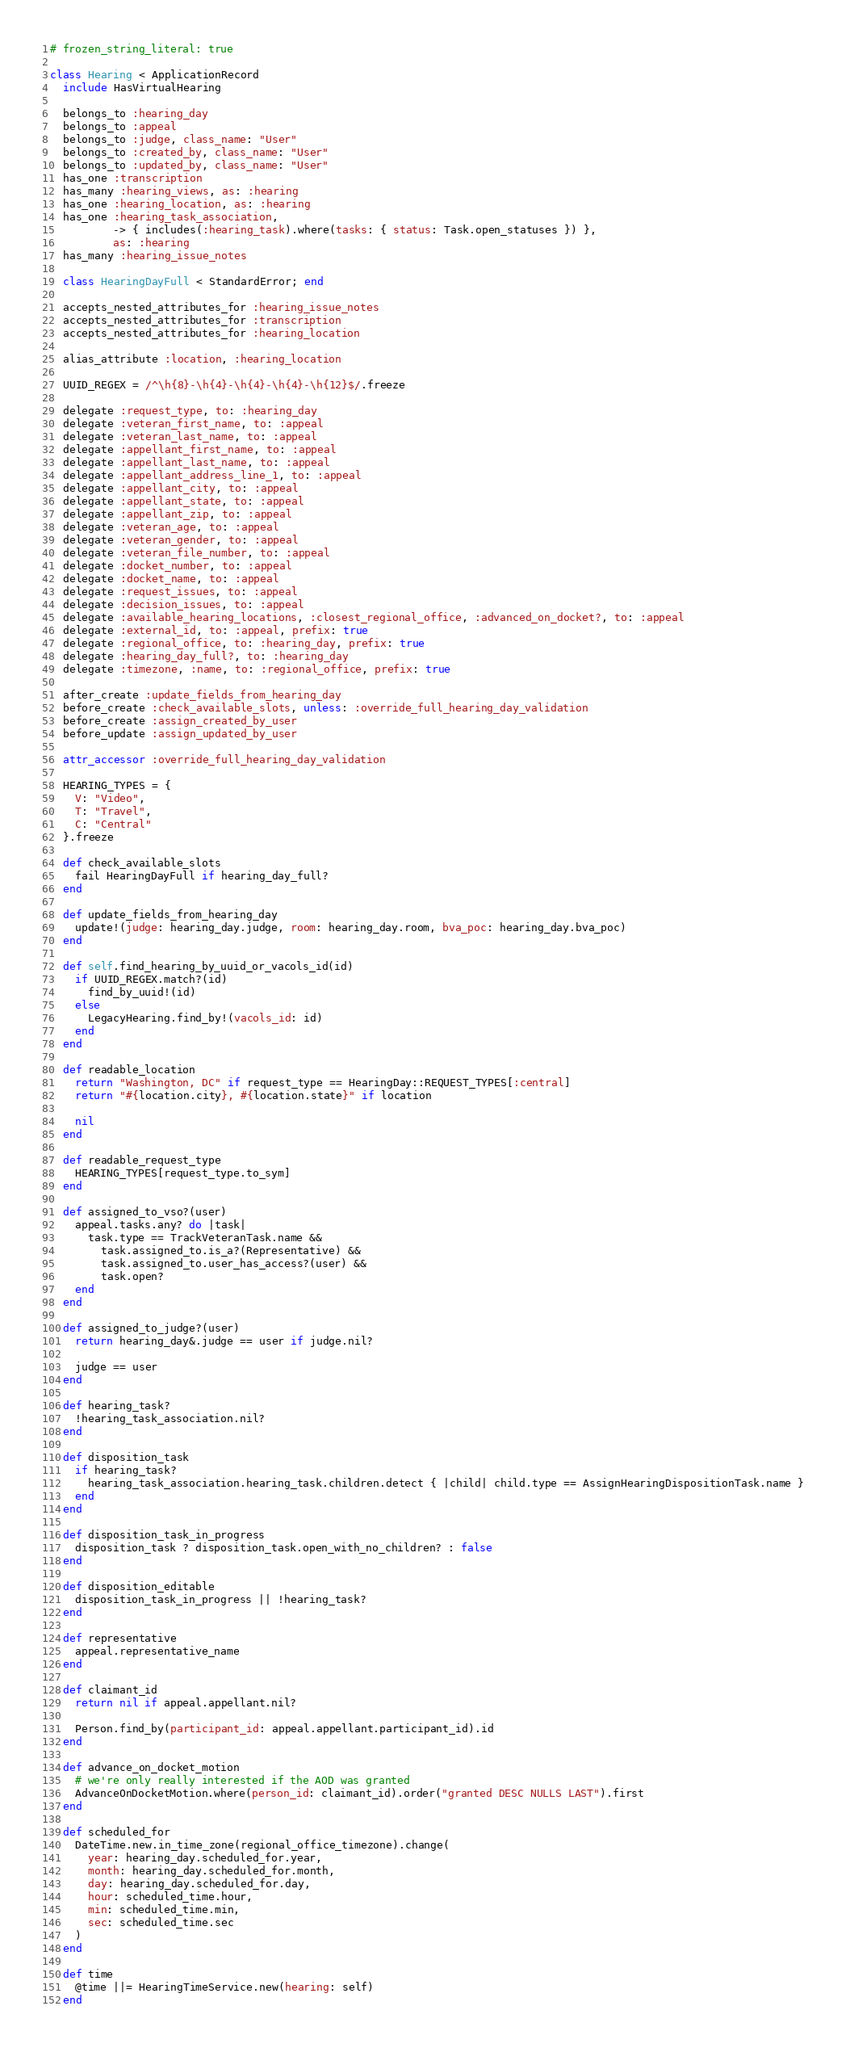<code> <loc_0><loc_0><loc_500><loc_500><_Ruby_># frozen_string_literal: true

class Hearing < ApplicationRecord
  include HasVirtualHearing

  belongs_to :hearing_day
  belongs_to :appeal
  belongs_to :judge, class_name: "User"
  belongs_to :created_by, class_name: "User"
  belongs_to :updated_by, class_name: "User"
  has_one :transcription
  has_many :hearing_views, as: :hearing
  has_one :hearing_location, as: :hearing
  has_one :hearing_task_association,
          -> { includes(:hearing_task).where(tasks: { status: Task.open_statuses }) },
          as: :hearing
  has_many :hearing_issue_notes

  class HearingDayFull < StandardError; end

  accepts_nested_attributes_for :hearing_issue_notes
  accepts_nested_attributes_for :transcription
  accepts_nested_attributes_for :hearing_location

  alias_attribute :location, :hearing_location

  UUID_REGEX = /^\h{8}-\h{4}-\h{4}-\h{4}-\h{12}$/.freeze

  delegate :request_type, to: :hearing_day
  delegate :veteran_first_name, to: :appeal
  delegate :veteran_last_name, to: :appeal
  delegate :appellant_first_name, to: :appeal
  delegate :appellant_last_name, to: :appeal
  delegate :appellant_address_line_1, to: :appeal
  delegate :appellant_city, to: :appeal
  delegate :appellant_state, to: :appeal
  delegate :appellant_zip, to: :appeal
  delegate :veteran_age, to: :appeal
  delegate :veteran_gender, to: :appeal
  delegate :veteran_file_number, to: :appeal
  delegate :docket_number, to: :appeal
  delegate :docket_name, to: :appeal
  delegate :request_issues, to: :appeal
  delegate :decision_issues, to: :appeal
  delegate :available_hearing_locations, :closest_regional_office, :advanced_on_docket?, to: :appeal
  delegate :external_id, to: :appeal, prefix: true
  delegate :regional_office, to: :hearing_day, prefix: true
  delegate :hearing_day_full?, to: :hearing_day
  delegate :timezone, :name, to: :regional_office, prefix: true

  after_create :update_fields_from_hearing_day
  before_create :check_available_slots, unless: :override_full_hearing_day_validation
  before_create :assign_created_by_user
  before_update :assign_updated_by_user

  attr_accessor :override_full_hearing_day_validation

  HEARING_TYPES = {
    V: "Video",
    T: "Travel",
    C: "Central"
  }.freeze

  def check_available_slots
    fail HearingDayFull if hearing_day_full?
  end

  def update_fields_from_hearing_day
    update!(judge: hearing_day.judge, room: hearing_day.room, bva_poc: hearing_day.bva_poc)
  end

  def self.find_hearing_by_uuid_or_vacols_id(id)
    if UUID_REGEX.match?(id)
      find_by_uuid!(id)
    else
      LegacyHearing.find_by!(vacols_id: id)
    end
  end

  def readable_location
    return "Washington, DC" if request_type == HearingDay::REQUEST_TYPES[:central]
    return "#{location.city}, #{location.state}" if location

    nil
  end

  def readable_request_type
    HEARING_TYPES[request_type.to_sym]
  end

  def assigned_to_vso?(user)
    appeal.tasks.any? do |task|
      task.type == TrackVeteranTask.name &&
        task.assigned_to.is_a?(Representative) &&
        task.assigned_to.user_has_access?(user) &&
        task.open?
    end
  end

  def assigned_to_judge?(user)
    return hearing_day&.judge == user if judge.nil?

    judge == user
  end

  def hearing_task?
    !hearing_task_association.nil?
  end

  def disposition_task
    if hearing_task?
      hearing_task_association.hearing_task.children.detect { |child| child.type == AssignHearingDispositionTask.name }
    end
  end

  def disposition_task_in_progress
    disposition_task ? disposition_task.open_with_no_children? : false
  end

  def disposition_editable
    disposition_task_in_progress || !hearing_task?
  end

  def representative
    appeal.representative_name
  end

  def claimant_id
    return nil if appeal.appellant.nil?

    Person.find_by(participant_id: appeal.appellant.participant_id).id
  end

  def advance_on_docket_motion
    # we're only really interested if the AOD was granted
    AdvanceOnDocketMotion.where(person_id: claimant_id).order("granted DESC NULLS LAST").first
  end

  def scheduled_for
    DateTime.new.in_time_zone(regional_office_timezone).change(
      year: hearing_day.scheduled_for.year,
      month: hearing_day.scheduled_for.month,
      day: hearing_day.scheduled_for.day,
      hour: scheduled_time.hour,
      min: scheduled_time.min,
      sec: scheduled_time.sec
    )
  end

  def time
    @time ||= HearingTimeService.new(hearing: self)
  end
</code> 